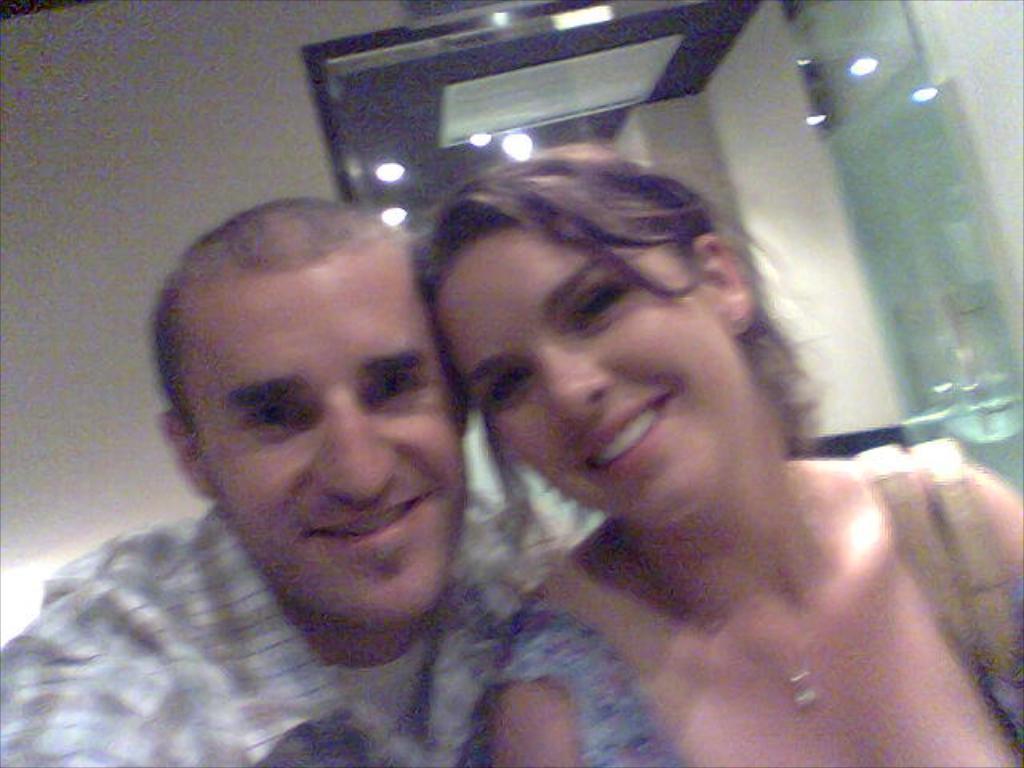How would you summarize this image in a sentence or two? This picture shows a man and a woman with smile on their faces and we see a mirror. 